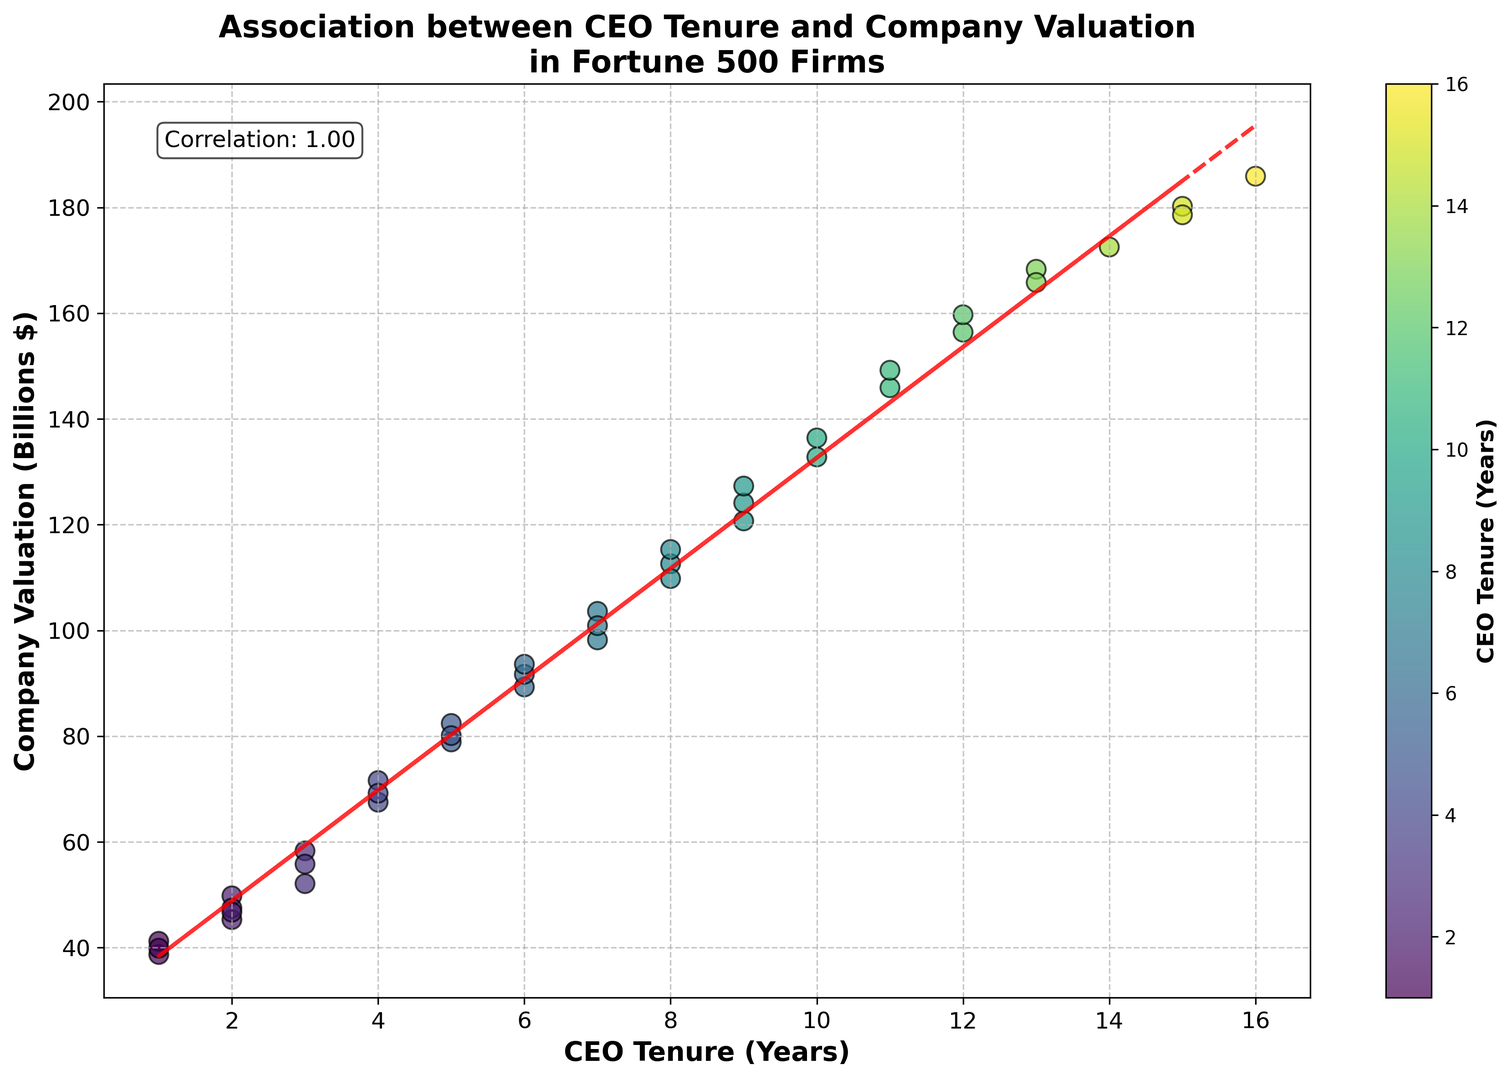What is the general trend between CEO tenure and company valuation displayed in the plot? The trend line in the scatter plot shows a positive slope, indicating that as CEO tenure increases, company valuation tends to increase.
Answer: Positive correlation Which CEO tenure is associated with the highest company valuation? The scatter plot shows that the highest company valuation is approximately $185.9 billion, which corresponds to a CEO tenure of 16 years.
Answer: 16 years What is the approximate correlation coefficient between CEO tenure and company valuation? The figure has a text annotation indicating that the correlation coefficient between CEO tenure and company valuation is 0.88.
Answer: 0.88 Compare the company valuation of a 4-year CEO tenure with a 6-year CEO tenure. Which is higher? According to the scatter plot, the company valuation corresponding to a 4-year CEO tenure is around $69.2 billion, whereas for a 6-year tenure, it's about $93.6 billion. The latter is higher.
Answer: 6-year tenure Identify the areas on the plot where there are no data points (in terms of CEO tenure years). Observing the scatter plot, there appear to be no data points corresponding to CEO tenures of 0 years and between 14 and 15 years.
Answer: 0 years, 14-15 years Which tenure range exhibits the most variation in company valuation based on the plot? The range from 1 to 3 years tenure shows a wider spread in company valuations, from approximately $38.7 billion to $58.3 billion, showing a higher variation compared to other ranges.
Answer: 1-3 years Is there any CEO tenure that appears more frequently in the plot, and what are the corresponding valuations? CEO tenures of 2, 5, and 7 years appear multiple times in the plot with valuations ranging roughly from $45.3 billion to $52.1 billion, $78.9 billion to $82.4 billion, and $98.2 billion to $103.6 billion, respectively.
Answer: 2, 5, and 7 years What can be inferred about a company with a CEO tenure of 15 years? The scatter plot shows that companies with a CEO tenure of 15 years are likely to have a high valuation, with a specific data point indicating around $178.6 billion.
Answer: Likely high valuation Does a shorter CEO tenure (1-3 years) generally associate with lower company valuations compared to longer tenures (13-16 years)? By comparing the concentration of points, shorter tenures (1-3 years) are associated with valuations between approximately $38.7 billion and $58.3 billion, while longer tenures (13-16 years) are associated with valuations ranging from around $156.4 billion to $185.9 billion, indicating generally higher valuations for longer tenures.
Answer: Yes What does the color on the scatter plot represent? The color on the scatter plot represents the number of years of CEO tenure, with a gradient range where different colors correspond to different lengths of tenure.
Answer: CEO tenure (years) 